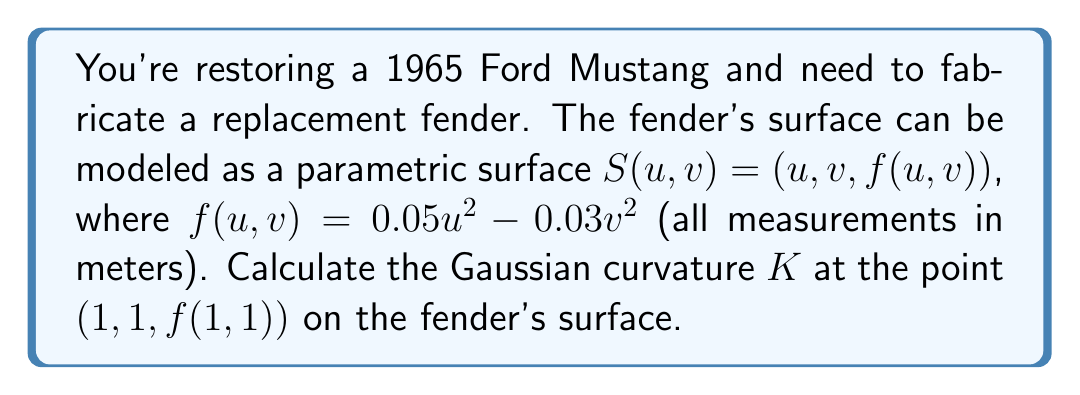Teach me how to tackle this problem. To calculate the Gaussian curvature of the fender's surface, we'll follow these steps:

1) First, we need to calculate the partial derivatives of $S(u,v)$:

   $S_u = (1, 0, 0.1u)$
   $S_v = (0, 1, -0.06v)$
   $S_{uu} = (0, 0, 0.1)$
   $S_{uv} = (0, 0, 0)$
   $S_{vv} = (0, 0, -0.06)$

2) Next, we calculate the normal vector $N$ to the surface:

   $N = S_u \times S_v = (-0.1u, 0.06v, 1)$

3) We then normalize this vector:

   $\|N\| = \sqrt{(-0.1u)^2 + (0.06v)^2 + 1^2}$
   
   $\hat{N} = \frac{(-0.1u, 0.06v, 1)}{\sqrt{0.01u^2 + 0.0036v^2 + 1}}$

4) Now we can calculate the coefficients of the first fundamental form:

   $E = S_u \cdot S_u = 1 + 0.01u^2$
   $F = S_u \cdot S_v = 0$
   $G = S_v \cdot S_v = 1 + 0.0036v^2$

5) And the coefficients of the second fundamental form:

   $e = S_{uu} \cdot \hat{N} = \frac{0.1}{\sqrt{0.01u^2 + 0.0036v^2 + 1}}$
   $f = S_{uv} \cdot \hat{N} = 0$
   $g = S_{vv} \cdot \hat{N} = \frac{-0.06}{\sqrt{0.01u^2 + 0.0036v^2 + 1}}$

6) The Gaussian curvature is given by:

   $K = \frac{eg - f^2}{EG - F^2}$

7) Substituting our values at the point (1, 1, f(1,1)):

   $K = \frac{(0.1)(-0.06) - 0^2}{(1.01)(1.0036) - 0^2} \cdot \frac{1}{0.01 + 0.0036 + 1}$

8) Simplifying:

   $K = \frac{-0.006}{1.013636} \cdot \frac{1}{1.0136} \approx -0.00585$
Answer: The Gaussian curvature $K$ at the point $(1, 1, f(1,1))$ on the fender's surface is approximately $-0.00585$ m^(-2). 